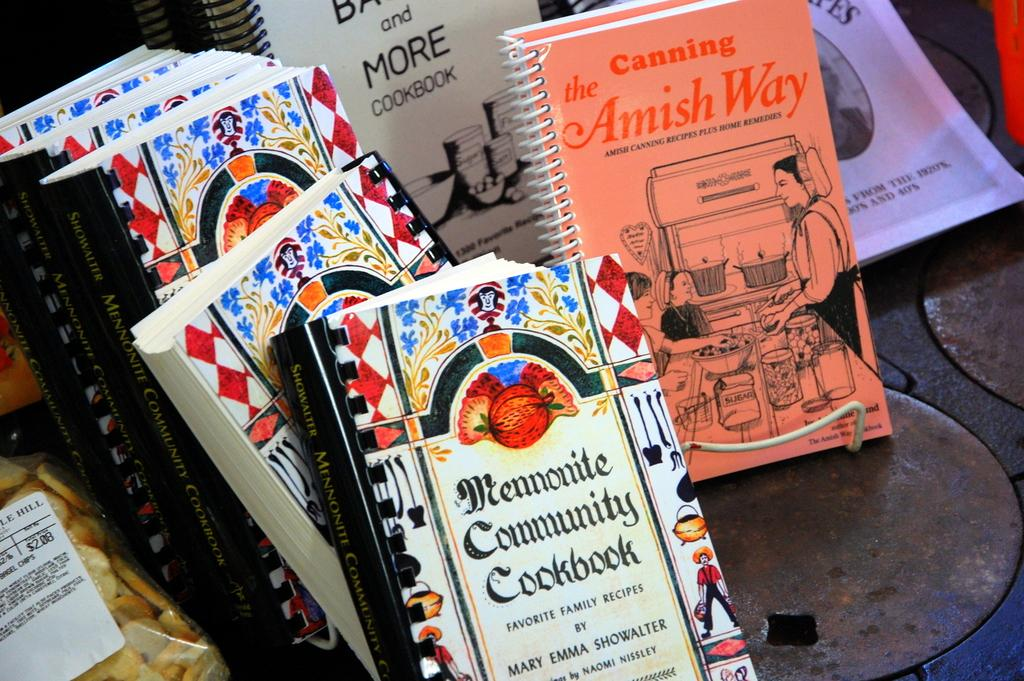<image>
Offer a succinct explanation of the picture presented. The Mennonite Community Cookbook in front of many other books 